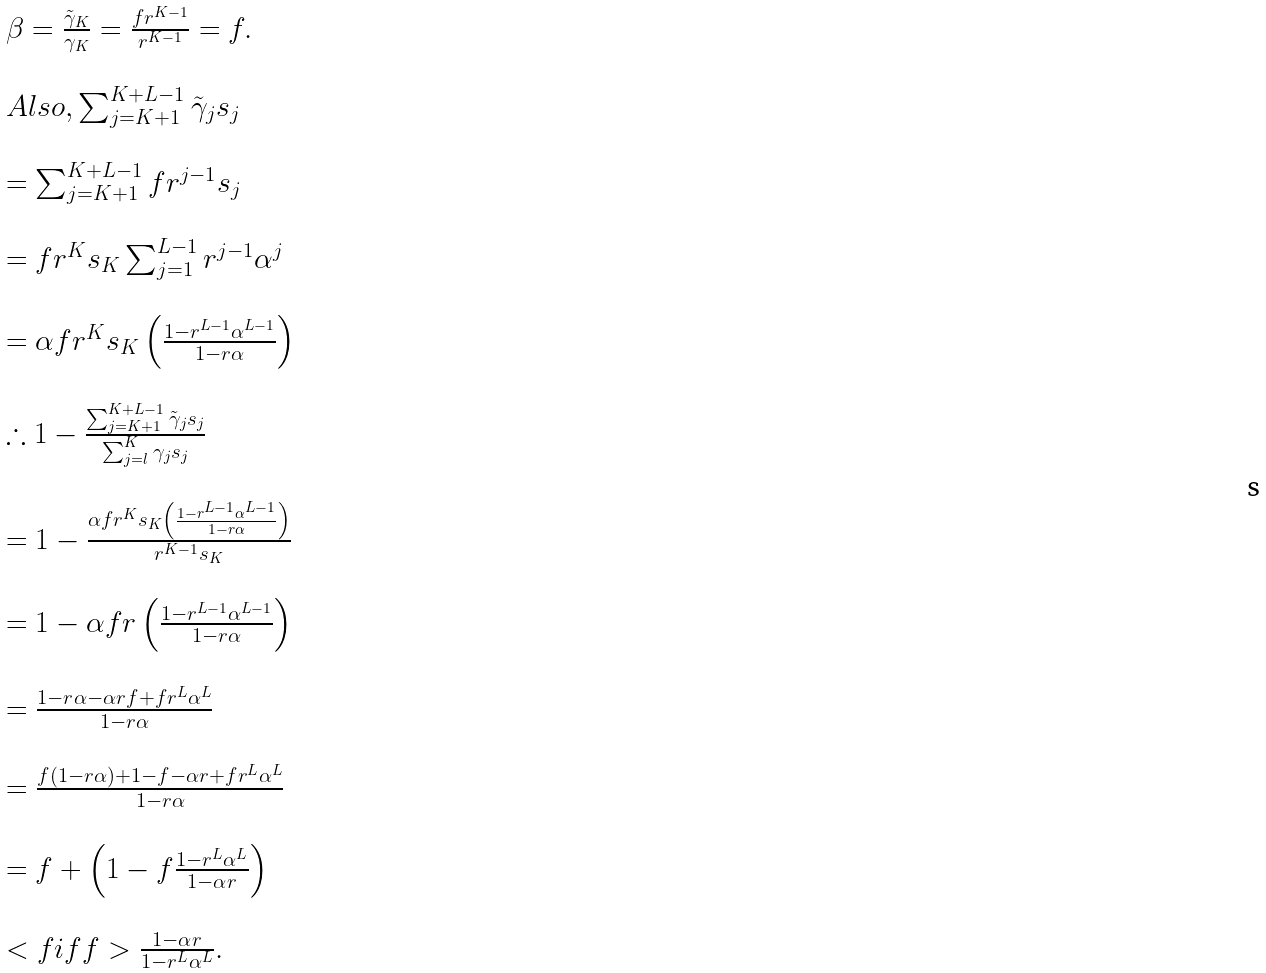Convert formula to latex. <formula><loc_0><loc_0><loc_500><loc_500>\begin{array} { l } \beta = \frac { \tilde { \gamma } _ { K } } { \gamma _ { K } } = \frac { f r ^ { K - 1 } } { r ^ { K - 1 } } = f . \\ \\ A l s o , \sum _ { j = K + 1 } ^ { K + L - 1 } \tilde { \gamma } _ { j } s _ { j } \\ \\ = \sum _ { j = K + 1 } ^ { K + L - 1 } f r ^ { j - 1 } s _ { j } \\ \\ = f r ^ { K } s _ { K } \sum _ { j = 1 } ^ { L - 1 } r ^ { j - 1 } \alpha ^ { j } \\ \\ = \alpha f r ^ { K } s _ { K } \left ( \frac { 1 - r ^ { L - 1 } \alpha ^ { L - 1 } } { 1 - r \alpha } \right ) \\ \\ \therefore 1 - \frac { \sum _ { j = K + 1 } ^ { K + L - 1 } \tilde { \gamma } _ { j } s _ { j } } { \sum _ { j = l } ^ { K } \gamma _ { j } s _ { j } } \\ \\ = 1 - \frac { \alpha f r ^ { K } s _ { K } \left ( \frac { 1 - r ^ { L - 1 } \alpha ^ { L - 1 } } { 1 - r \alpha } \right ) } { r ^ { K - 1 } s _ { K } } \\ \\ = 1 - \alpha f r \left ( \frac { 1 - r ^ { L - 1 } \alpha ^ { L - 1 } } { 1 - r \alpha } \right ) \\ \\ = \frac { 1 - r \alpha - \alpha r f + f r ^ { L } \alpha ^ { L } } { 1 - r \alpha } \\ \\ = \frac { f ( 1 - r \alpha ) + 1 - f - \alpha r + f r ^ { L } \alpha ^ { L } } { 1 - r \alpha } \\ \\ = f + \left ( 1 - f \frac { 1 - r ^ { L } \alpha ^ { L } } { 1 - \alpha r } \right ) \\ \\ < f i f f > \frac { 1 - \alpha r } { 1 - r ^ { L } \alpha ^ { L } } . \end{array}</formula> 